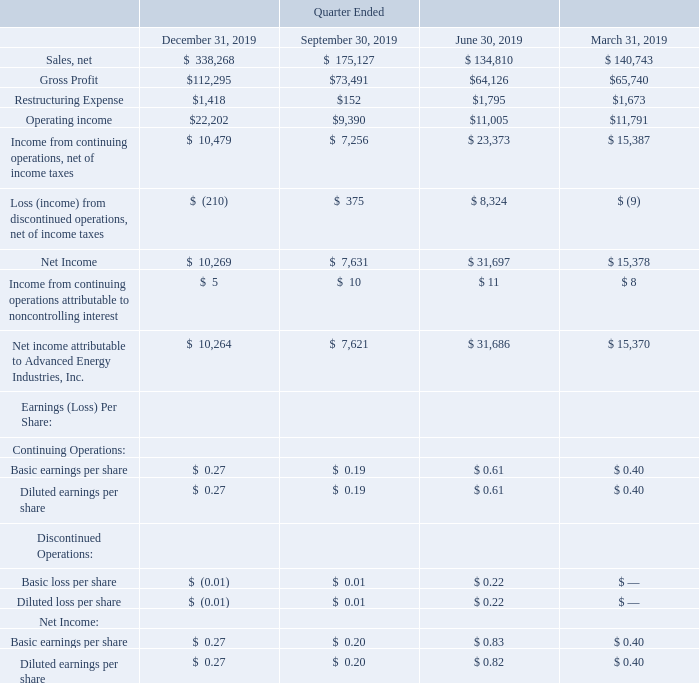ADVANCED ENERGY INDUSTRIES, INC. NOTES TO CONSOLIDATED FINANCIAL STATEMENTS – (continued) (in thousands, except per share amounts)
NOTE 23. SUPPLEMENTAL QUARTERLY FINANCIAL DATA (UNAUDITED)
The following tables present unaudited quarterly results for each of the eight quarters in the periods ended December 31, 2019 and 2018, in thousands. We believe that all necessary adjustments have been included in the amounts stated below to present fairly such quarterly information. Due to the volatility of the industries in which our customers operate, the operating results for any quarter are not necessarily indicative of results for any subsequent period.
What was the restructuring expense in  Quarter Ended  December?
Answer scale should be: thousand. $1,418. Why are the operating results for any quarter not necessarily indicative of results for any subsequent period? Volatility of the industries in which our customers operate. What was the operating income in Quarter Ended  September?
Answer scale should be: thousand. $9,390. What was the change in restructuring expense between Quarter Ended  September and December?
Answer scale should be: thousand. $1,418-$152
Answer: 1266. What was the change in gross profit between Quarter Ended  March and June?
Answer scale should be: thousand. $64,126-$65,740
Answer: -1614. What was the percentage change in Operating income between Quarter Ended  June and September?
Answer scale should be: percent. ($9,390-$11,005)/$11,005
Answer: -14.68. 